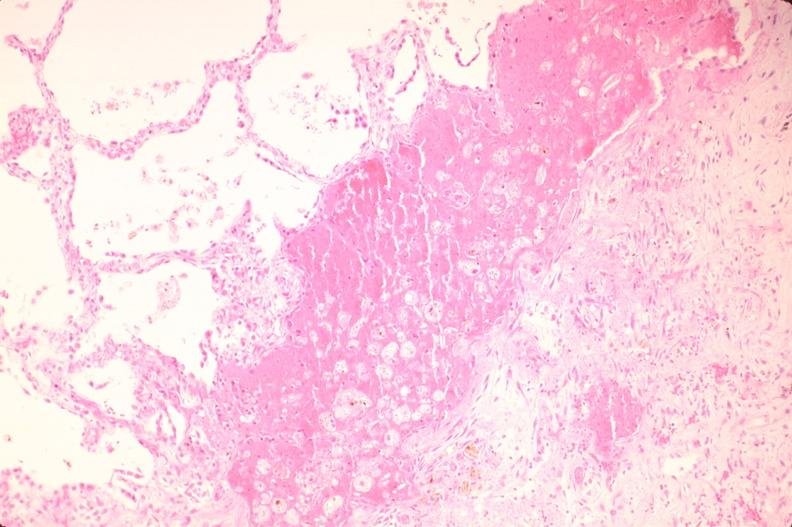s digital infarcts bacterial endocarditis present?
Answer the question using a single word or phrase. No 